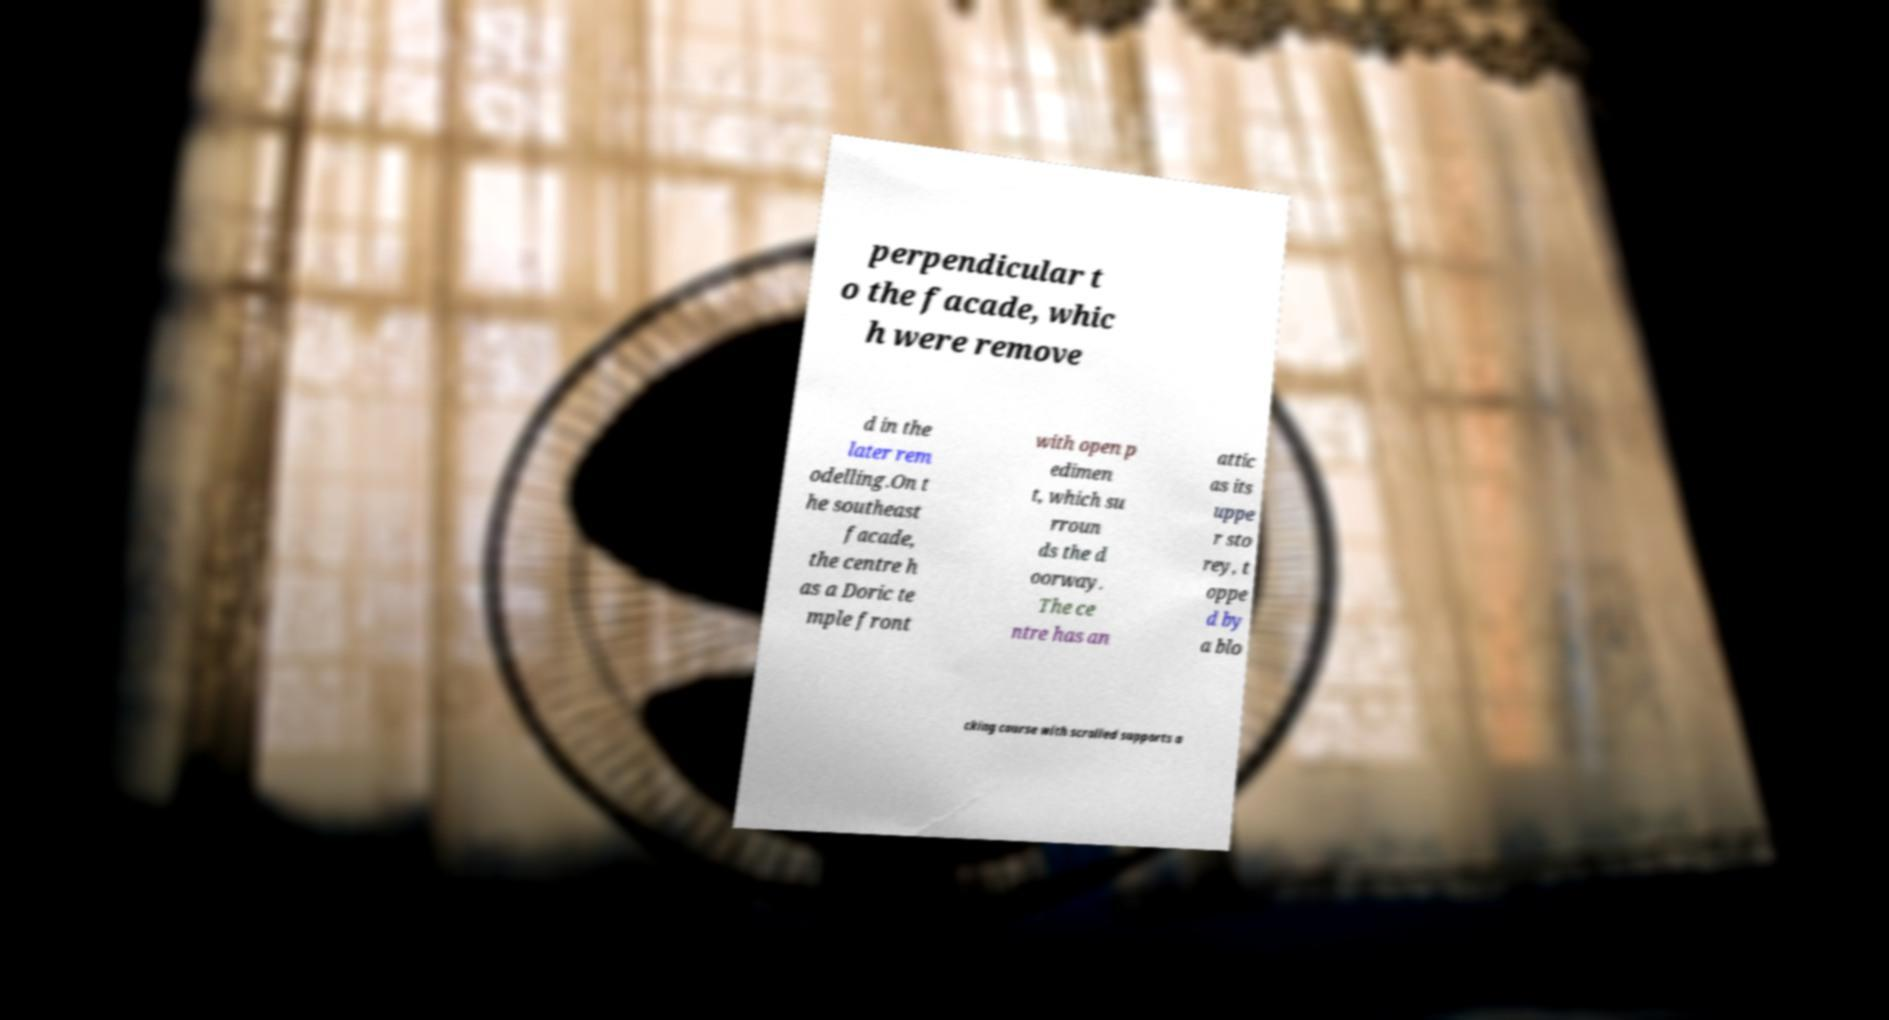Could you extract and type out the text from this image? perpendicular t o the facade, whic h were remove d in the later rem odelling.On t he southeast facade, the centre h as a Doric te mple front with open p edimen t, which su rroun ds the d oorway. The ce ntre has an attic as its uppe r sto rey, t oppe d by a blo cking course with scrolled supports a 